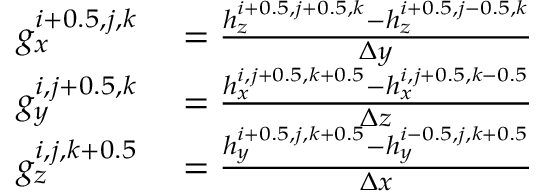Convert formula to latex. <formula><loc_0><loc_0><loc_500><loc_500>\begin{array} { r l } { g _ { x } ^ { i + 0 . 5 , j , k } } & = \frac { h _ { z } ^ { i + 0 . 5 , j + 0 . 5 , k } - h _ { z } ^ { i + 0 . 5 , j - 0 . 5 , k } } { \Delta y } } \\ { g _ { y } ^ { i , j + 0 . 5 , k } } & = \frac { h _ { x } ^ { i , j + 0 . 5 , k + 0 . 5 } - h _ { x } ^ { i , j + 0 . 5 , k - 0 . 5 } } { \Delta z } } \\ { g _ { z } ^ { i , j , k + 0 . 5 } } & = \frac { h _ { y } ^ { i + 0 . 5 , j , k + 0 . 5 } - h _ { y } ^ { i - 0 . 5 , j , k + 0 . 5 } } { \Delta x } } \end{array}</formula> 